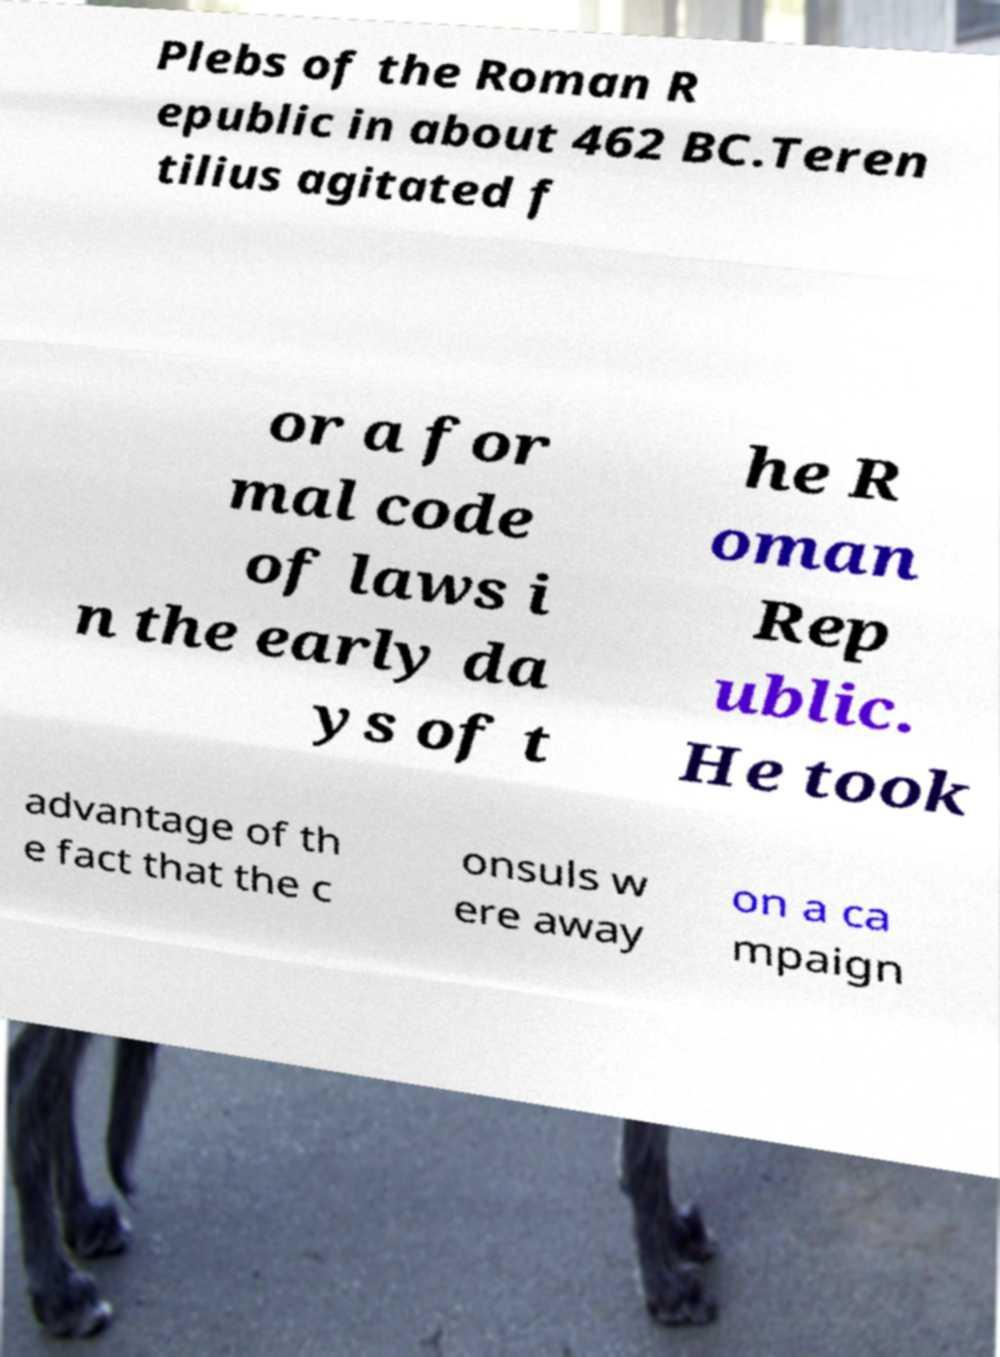Can you read and provide the text displayed in the image?This photo seems to have some interesting text. Can you extract and type it out for me? Plebs of the Roman R epublic in about 462 BC.Teren tilius agitated f or a for mal code of laws i n the early da ys of t he R oman Rep ublic. He took advantage of th e fact that the c onsuls w ere away on a ca mpaign 